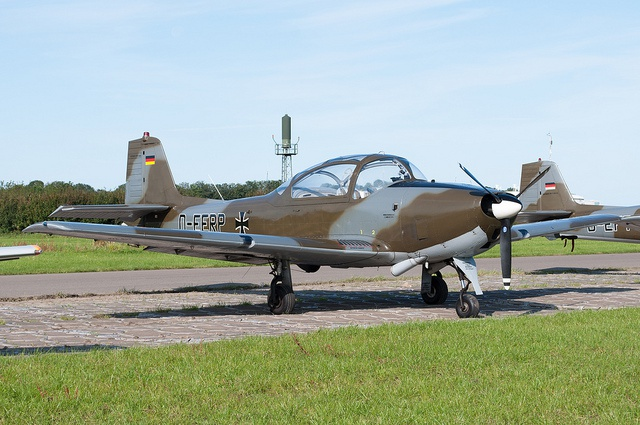Describe the objects in this image and their specific colors. I can see airplane in lightblue, gray, darkgray, and black tones and airplane in lightblue, gray, darkgray, and lightgray tones in this image. 